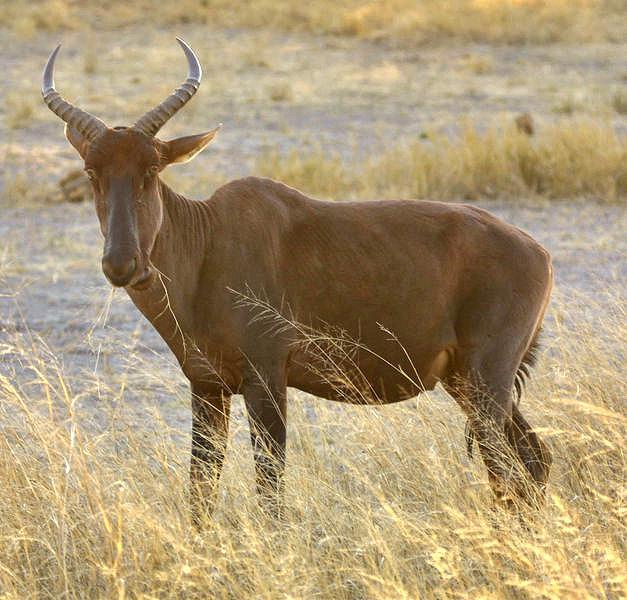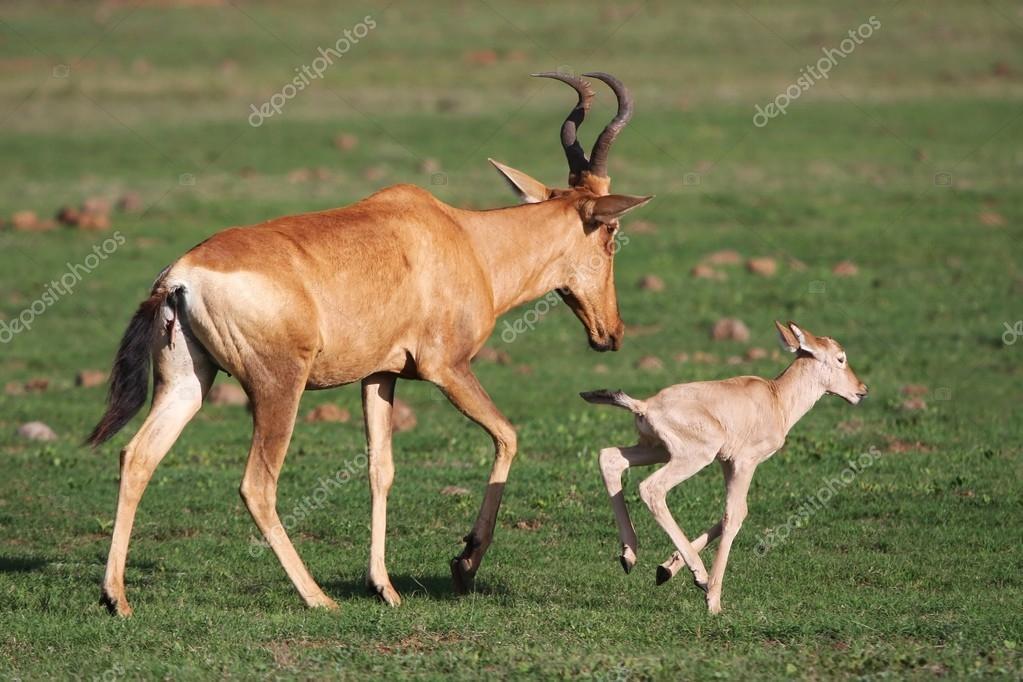The first image is the image on the left, the second image is the image on the right. Analyze the images presented: Is the assertion "An image shows a rightward-facing adult horned animal and young hornless animal, one ahead of the other but not overlapping." valid? Answer yes or no. Yes. 